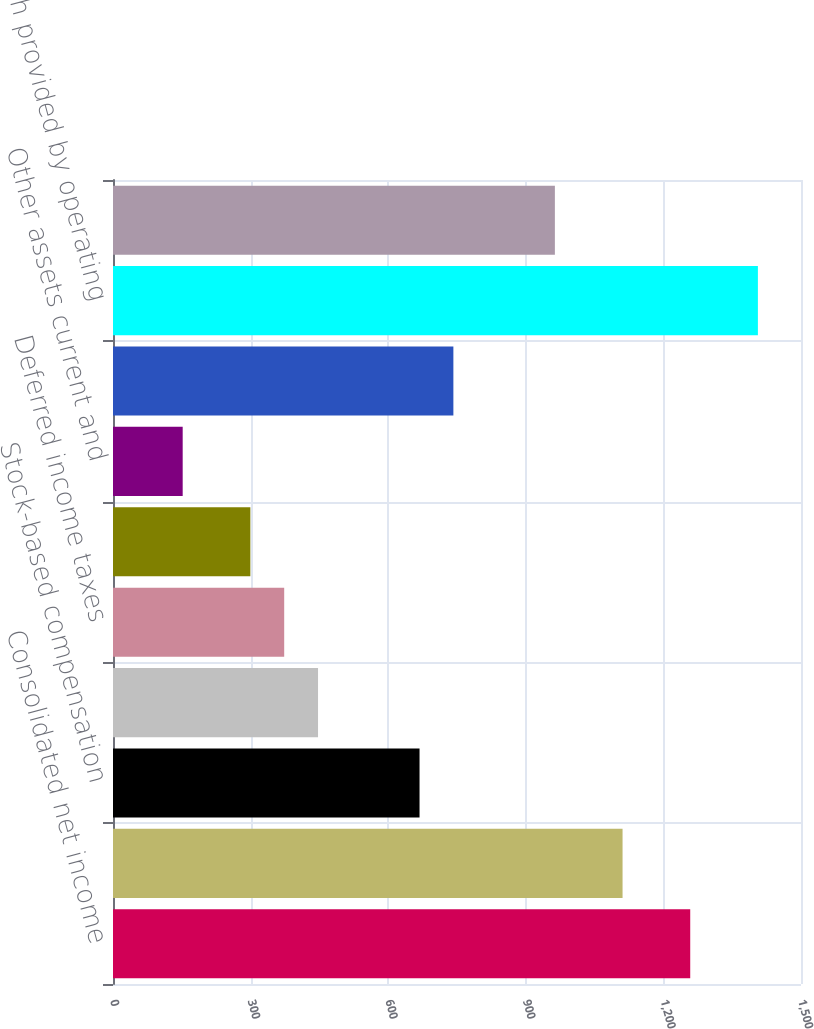Convert chart. <chart><loc_0><loc_0><loc_500><loc_500><bar_chart><fcel>Consolidated net income<fcel>Depreciation and amortization<fcel>Stock-based compensation<fcel>Excess tax benefits from<fcel>Deferred income taxes<fcel>Accounts receivable net<fcel>Other assets current and<fcel>Current and long-term<fcel>Cash provided by operating<fcel>Capital expenditures<nl><fcel>1258.49<fcel>1110.95<fcel>668.33<fcel>447.02<fcel>373.25<fcel>299.48<fcel>151.94<fcel>742.1<fcel>1406.03<fcel>963.41<nl></chart> 